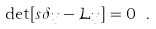Convert formula to latex. <formula><loc_0><loc_0><loc_500><loc_500>\det [ s \delta _ { i j } - \mathcal { L } _ { i j } ] = 0 \ .</formula> 